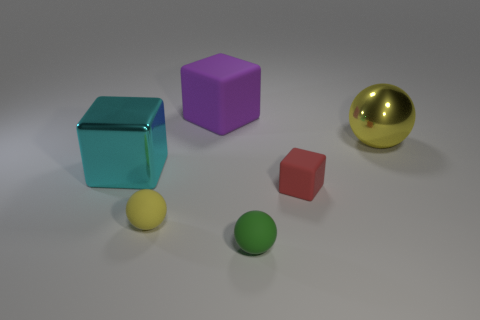What number of objects are either yellow rubber things or tiny yellow matte cylinders?
Give a very brief answer. 1. Does the large sphere that is on the right side of the small red rubber object have the same material as the tiny green thing?
Provide a succinct answer. No. How many things are matte balls behind the tiny green matte thing or tiny shiny cylinders?
Provide a short and direct response. 1. What color is the other sphere that is made of the same material as the green sphere?
Offer a terse response. Yellow. Are there any gray metal cylinders of the same size as the metal block?
Provide a short and direct response. No. Is the color of the rubber thing behind the red cube the same as the large sphere?
Provide a succinct answer. No. There is a object that is left of the purple matte object and on the right side of the large shiny block; what color is it?
Provide a short and direct response. Yellow. There is a cyan thing that is the same size as the shiny sphere; what shape is it?
Your answer should be compact. Cube. Are there any small yellow rubber objects that have the same shape as the red rubber thing?
Provide a succinct answer. No. There is a block that is behind the yellow shiny ball; is its size the same as the green thing?
Keep it short and to the point. No. 